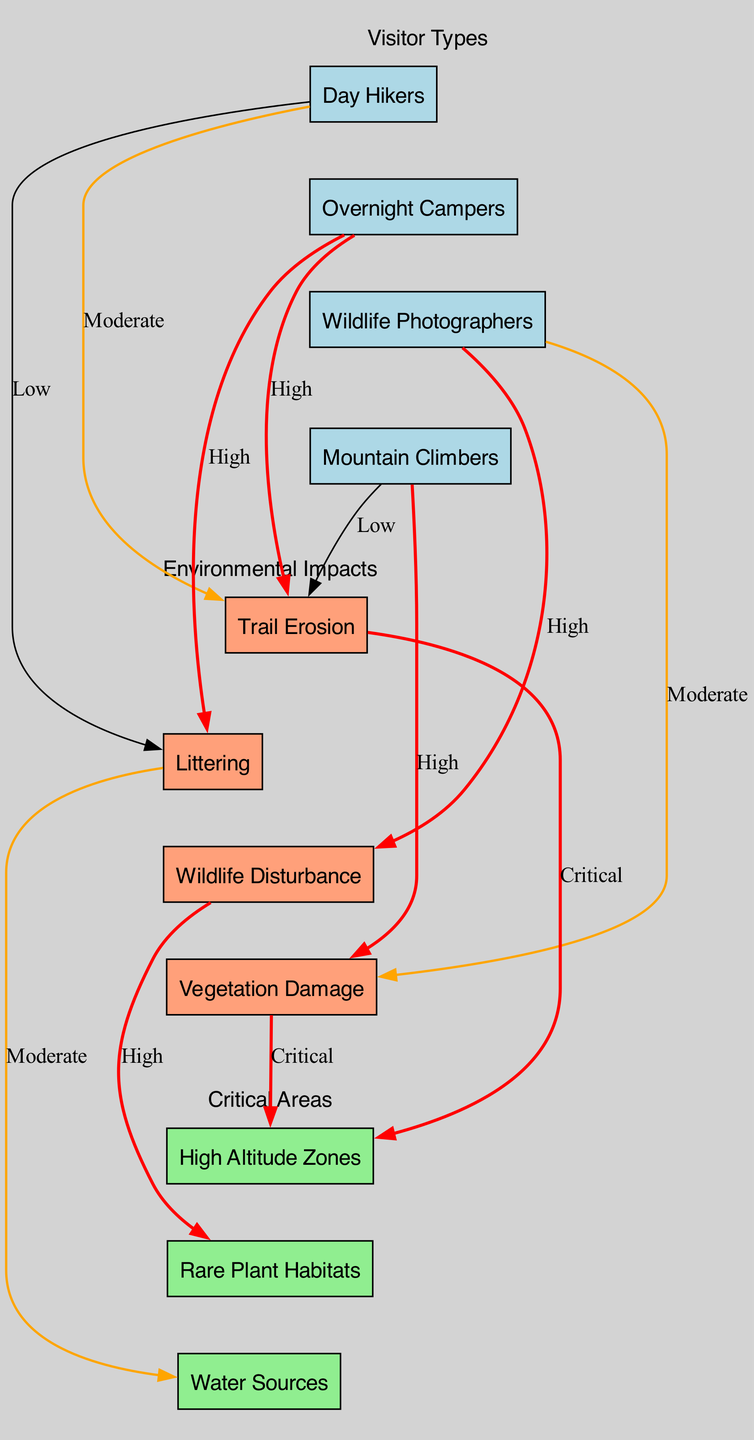What are the types of visitors represented in the diagram? The diagram includes four types of visitors labeled as "Day Hikers," "Overnight Campers," "Wildlife Photographers," and "Mountain Climbers." Each is represented with its own node connecting to various impacts.
Answer: Day Hikers, Overnight Campers, Wildlife Photographers, Mountain Climbers Which visitor type is linked to the highest environmental impact? The "Overnight Campers" have links to both "Trail Erosion" and "Littering," both labeled as "High," indicating significant impacts compared to other visitor types.
Answer: Overnight Campers How many types of environmental impacts are shown in the diagram? The diagram includes four environmental impacts: "Trail Erosion," "Littering," "Wildlife Disturbance," and "Vegetation Damage." Each is represented as a distinct node.
Answer: Four Which critical area is affected by "Wildlife Disturbance"? The edge from "Wildlife Disturbance" leads to "Rare Plant Habitats," which is labeled as "High," indicating that this area is significantly impacted by that specific visitor behavior.
Answer: Rare Plant Habitats What is the connection type between "Trail Erosion" and "High Altitude Zones"? The link between "Trail Erosion" and "High Altitude Zones" is designated as "Critical," showing a severe impact on this critical area from that specific environmental issue.
Answer: Critical Which visitor type has the lowest impact associated with littering? "Day Hikers" show a low impact associated with littering as indicated by the connection with "Littering" labeled as "Low." No other visitor type has a lower rating.
Answer: Day Hikers What is the significance of the edge label “High” in the diagram? The edges labeled as “High” indicate a severe level of impact that specific visitor types have on environmental aspects, requiring immediate attention in conservation efforts.
Answer: Severe How is "Vegetation Damage" primarily related to visitor behavior? The "Vegetation Damage" impact is primarily related to "Wildlife Photographers," with a moderate impact showing that their behavior can affect vegetation in alpine ecosystems.
Answer: Wildlife Photographers How many nodes are classified as critical areas in the diagram? There are three nodes classified as critical areas: "High Altitude Zones," "Rare Plant Habitats," and "Water Sources," indicating multiple zones need protection.
Answer: Three 